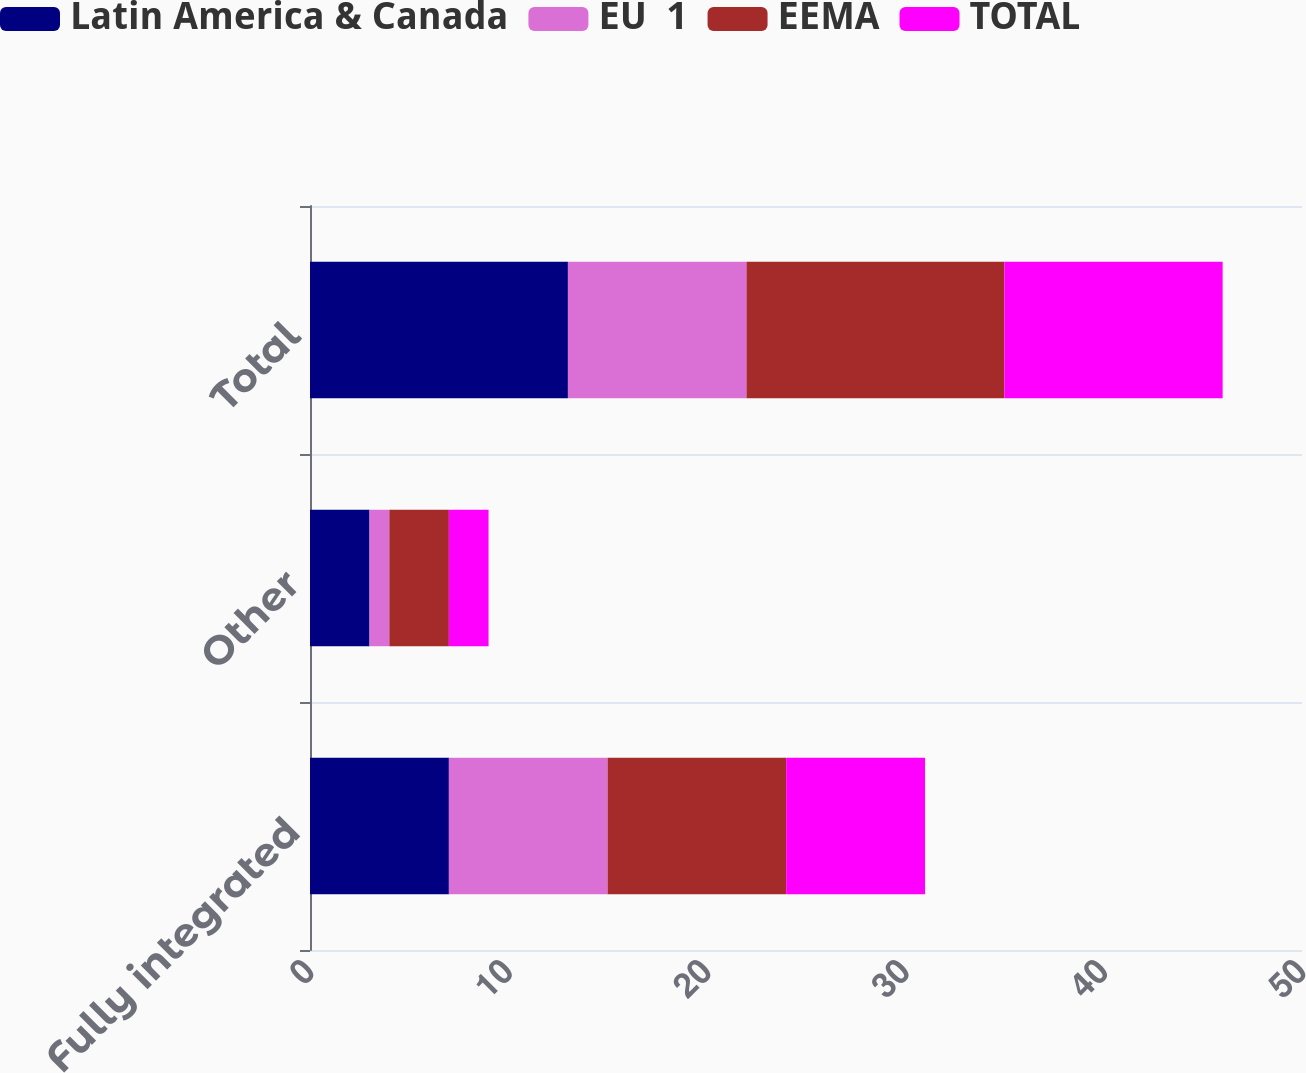Convert chart. <chart><loc_0><loc_0><loc_500><loc_500><stacked_bar_chart><ecel><fcel>Fully integrated<fcel>Other<fcel>Total<nl><fcel>Latin America & Canada<fcel>7<fcel>3<fcel>13<nl><fcel>EU  1<fcel>8<fcel>1<fcel>9<nl><fcel>EEMA<fcel>9<fcel>3<fcel>13<nl><fcel>TOTAL<fcel>7<fcel>2<fcel>11<nl></chart> 